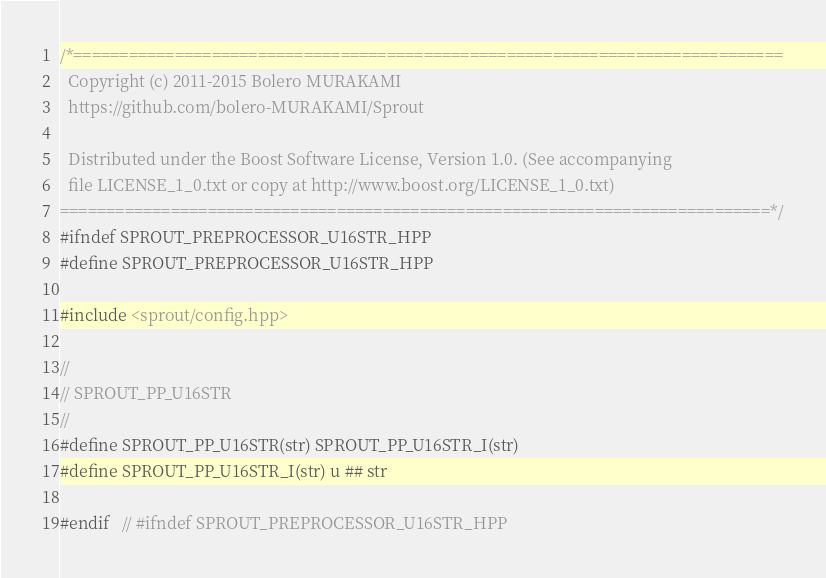Convert code to text. <code><loc_0><loc_0><loc_500><loc_500><_C++_>/*=============================================================================
  Copyright (c) 2011-2015 Bolero MURAKAMI
  https://github.com/bolero-MURAKAMI/Sprout

  Distributed under the Boost Software License, Version 1.0. (See accompanying
  file LICENSE_1_0.txt or copy at http://www.boost.org/LICENSE_1_0.txt)
=============================================================================*/
#ifndef SPROUT_PREPROCESSOR_U16STR_HPP
#define SPROUT_PREPROCESSOR_U16STR_HPP

#include <sprout/config.hpp>

//
// SPROUT_PP_U16STR
//
#define SPROUT_PP_U16STR(str) SPROUT_PP_U16STR_I(str)
#define SPROUT_PP_U16STR_I(str) u ## str

#endif	// #ifndef SPROUT_PREPROCESSOR_U16STR_HPP
</code> 